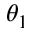Convert formula to latex. <formula><loc_0><loc_0><loc_500><loc_500>\theta _ { 1 }</formula> 